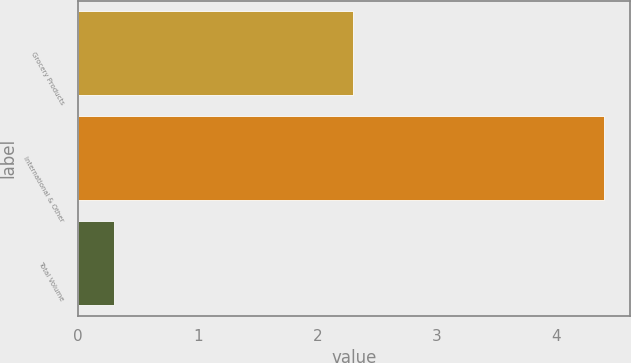Convert chart to OTSL. <chart><loc_0><loc_0><loc_500><loc_500><bar_chart><fcel>Grocery Products<fcel>International & Other<fcel>Total Volume<nl><fcel>2.3<fcel>4.4<fcel>0.3<nl></chart> 